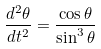<formula> <loc_0><loc_0><loc_500><loc_500>\frac { d ^ { 2 } \theta } { d t ^ { 2 } } = \frac { \cos \theta } { \sin ^ { 3 } \theta }</formula> 